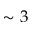<formula> <loc_0><loc_0><loc_500><loc_500>\sim 3</formula> 